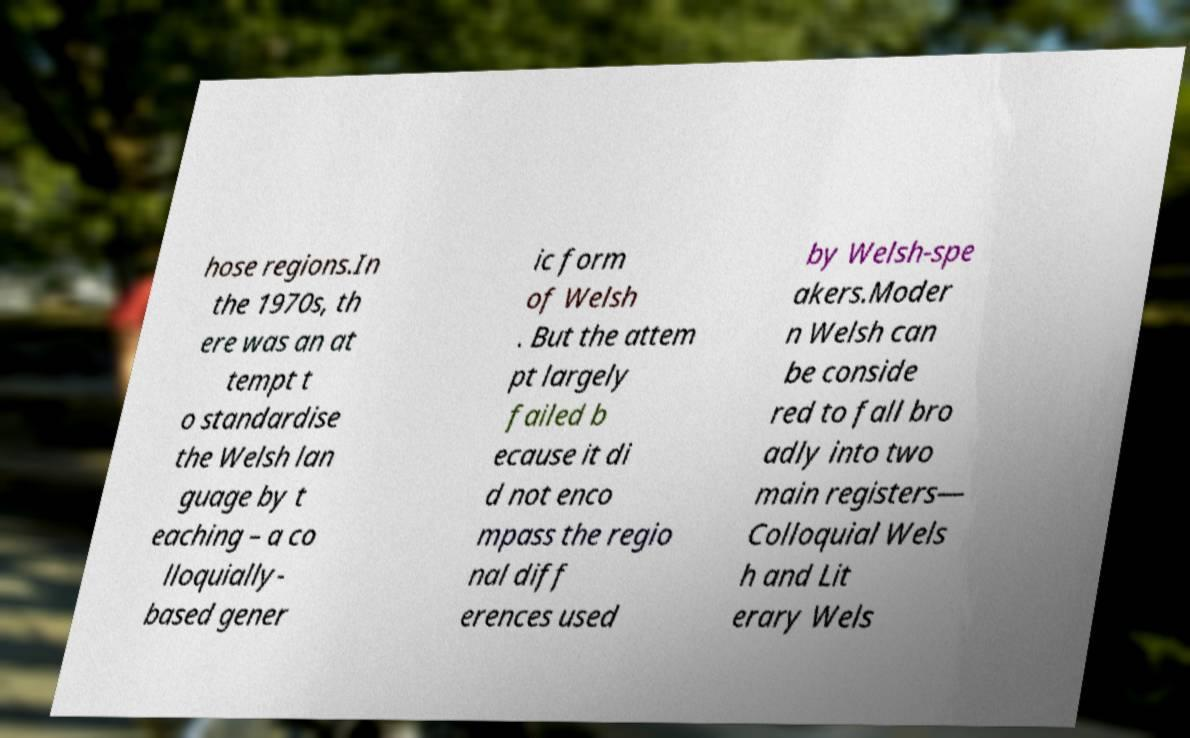Please read and relay the text visible in this image. What does it say? hose regions.In the 1970s, th ere was an at tempt t o standardise the Welsh lan guage by t eaching – a co lloquially- based gener ic form of Welsh . But the attem pt largely failed b ecause it di d not enco mpass the regio nal diff erences used by Welsh-spe akers.Moder n Welsh can be conside red to fall bro adly into two main registers— Colloquial Wels h and Lit erary Wels 